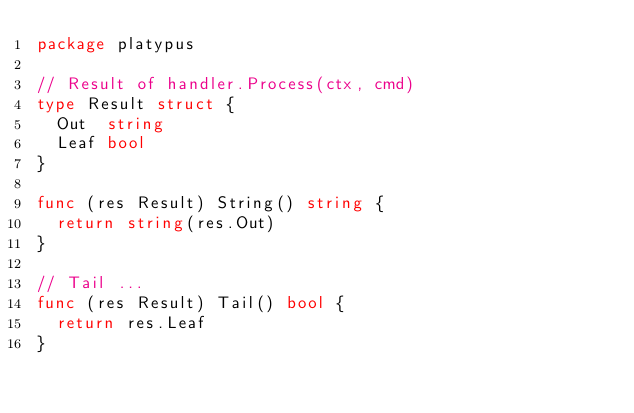Convert code to text. <code><loc_0><loc_0><loc_500><loc_500><_Go_>package platypus

// Result of handler.Process(ctx, cmd)
type Result struct {
	Out  string
	Leaf bool
}

func (res Result) String() string {
	return string(res.Out)
}

// Tail ...
func (res Result) Tail() bool {
	return res.Leaf
}
</code> 